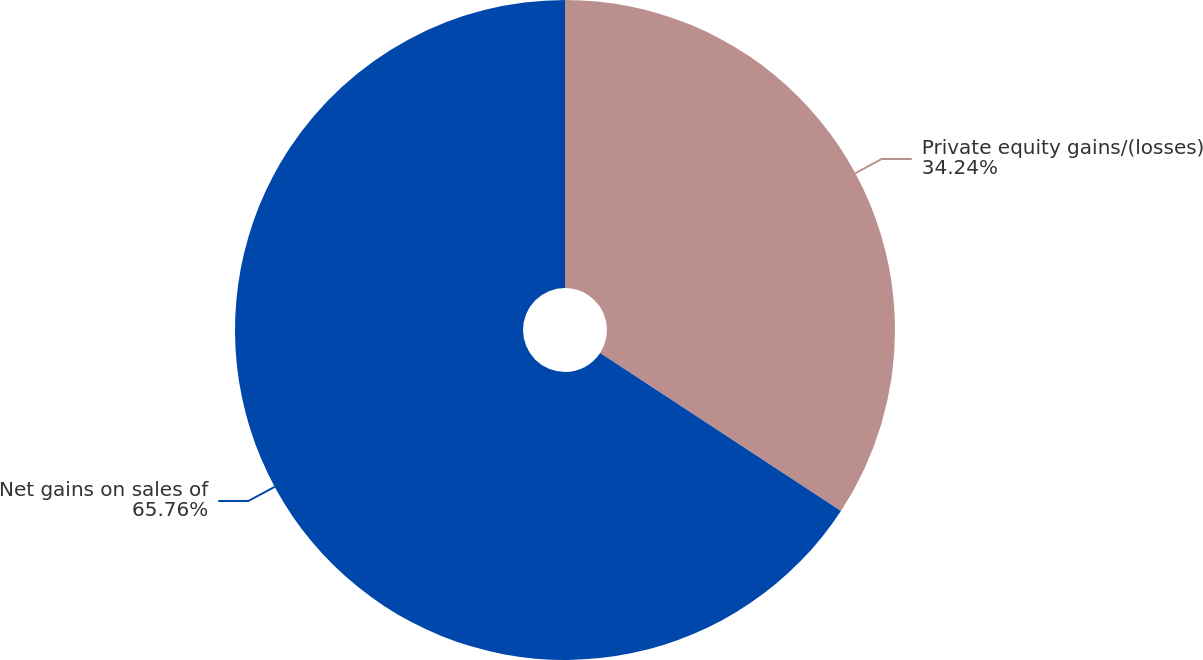Convert chart to OTSL. <chart><loc_0><loc_0><loc_500><loc_500><pie_chart><fcel>Private equity gains/(losses)<fcel>Net gains on sales of<nl><fcel>34.24%<fcel>65.76%<nl></chart> 